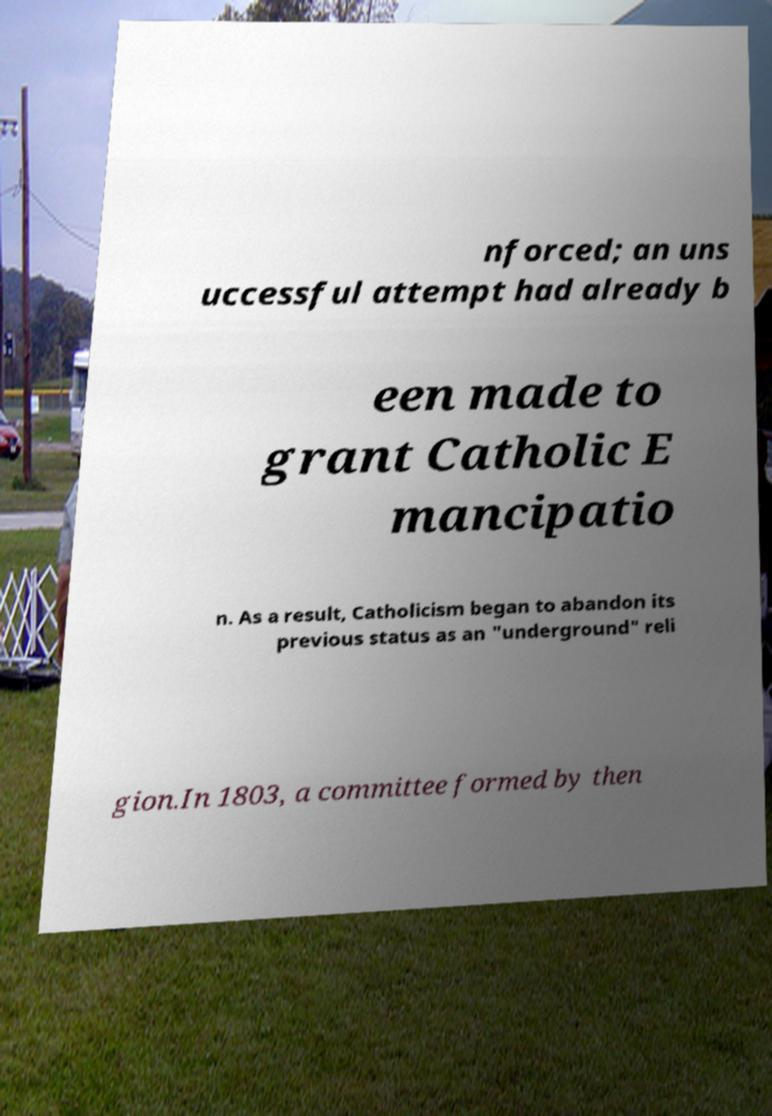Please read and relay the text visible in this image. What does it say? nforced; an uns uccessful attempt had already b een made to grant Catholic E mancipatio n. As a result, Catholicism began to abandon its previous status as an "underground" reli gion.In 1803, a committee formed by then 